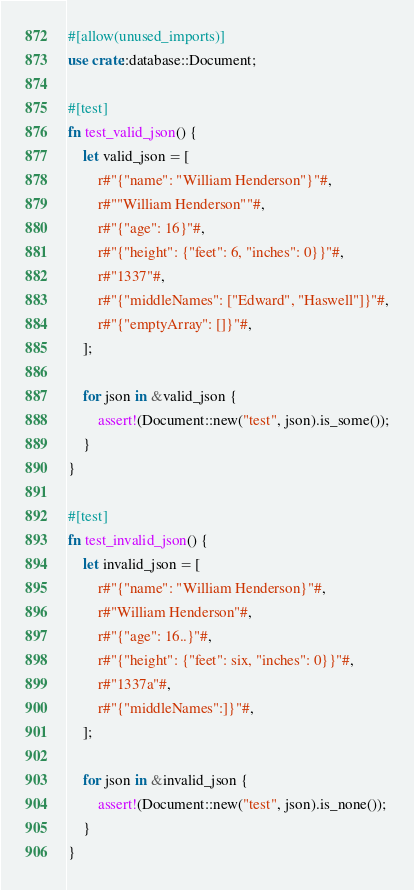Convert code to text. <code><loc_0><loc_0><loc_500><loc_500><_Rust_>#[allow(unused_imports)]
use crate::database::Document;

#[test]
fn test_valid_json() {
    let valid_json = [
        r#"{"name": "William Henderson"}"#,
        r#""William Henderson""#,
        r#"{"age": 16}"#,
        r#"{"height": {"feet": 6, "inches": 0}}"#,
        r#"1337"#,
        r#"{"middleNames": ["Edward", "Haswell"]}"#,
        r#"{"emptyArray": []}"#,
    ];

    for json in &valid_json {
        assert!(Document::new("test", json).is_some());
    }
}

#[test]
fn test_invalid_json() {
    let invalid_json = [
        r#"{"name": "William Henderson}"#,
        r#"William Henderson"#,
        r#"{"age": 16..}"#,
        r#"{"height": {"feet": six, "inches": 0}}"#,
        r#"1337a"#,
        r#"{"middleNames":]}"#,
    ];

    for json in &invalid_json {
        assert!(Document::new("test", json).is_none());
    }
}
</code> 